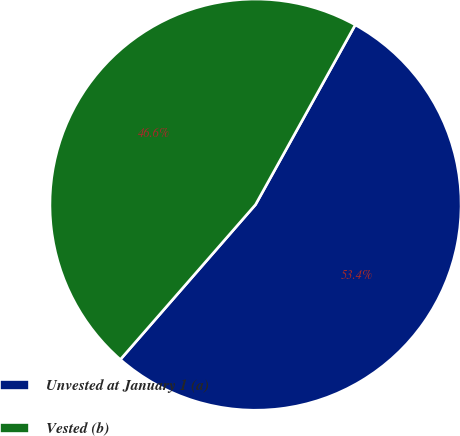Convert chart. <chart><loc_0><loc_0><loc_500><loc_500><pie_chart><fcel>Unvested at January 1 (a)<fcel>Vested (b)<nl><fcel>53.36%<fcel>46.64%<nl></chart> 